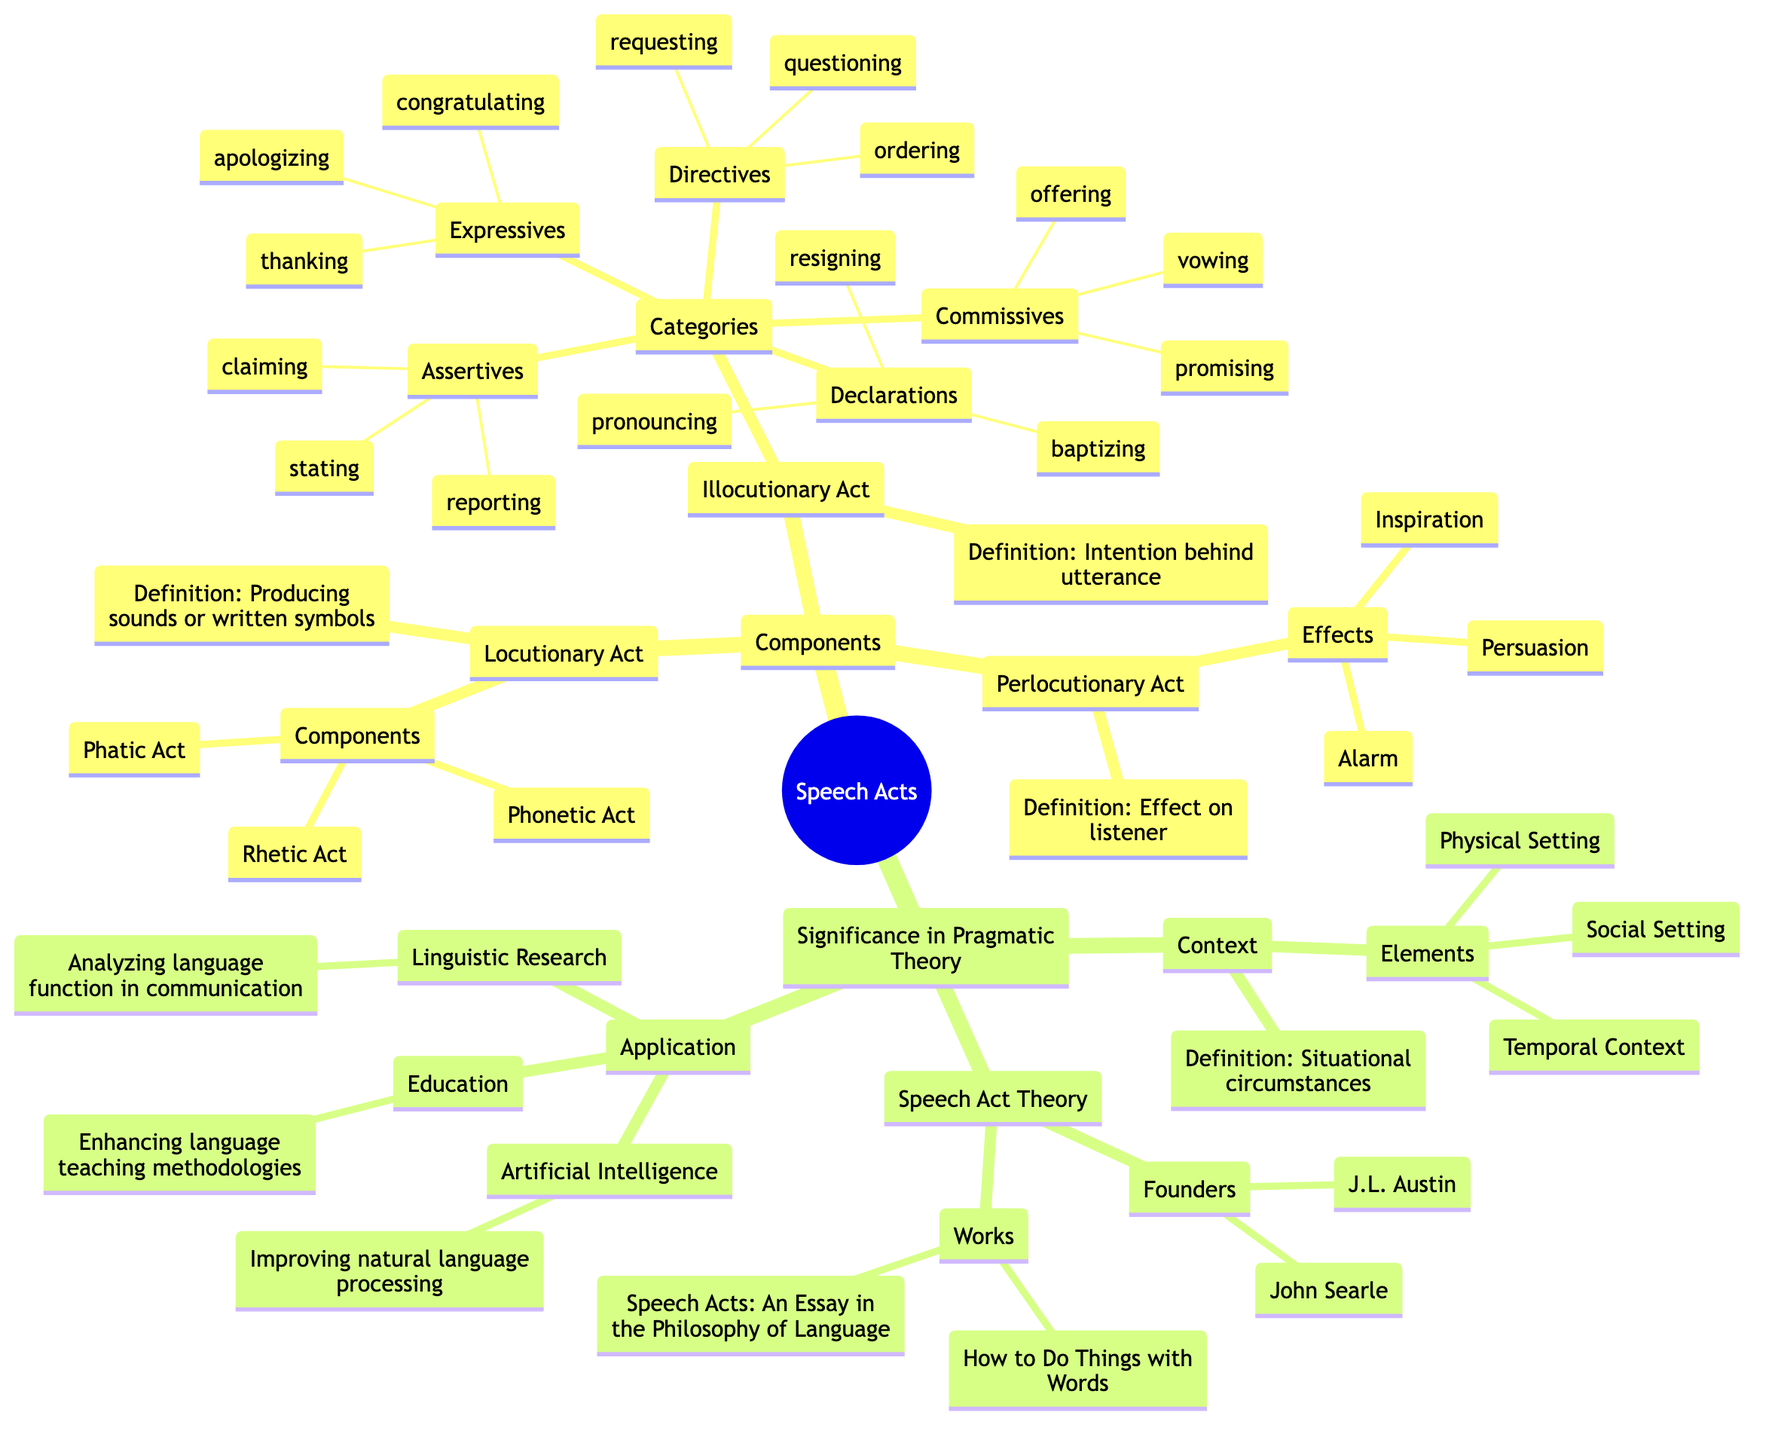What are the components of a Locutionary Act? According to the diagram, a Locutionary Act consists of three components: Phonetic Act, Phatic Act, and Rhetic Act.
Answer: Phonetic Act, Phatic Act, Rhetic Act Who are the founders of Speech Act Theory? The diagram identifies J.L. Austin and John Searle as the founders of Speech Act Theory.
Answer: J.L. Austin, John Searle What is the definition of an Illocutionary Act? The diagram defines an Illocutionary Act as the intention behind the utterance.
Answer: Intention behind utterance How many categories are there in Illocutionary Acts? The diagram lists five categories of Illocutionary Acts: Assertives, Directives, Commissives, Expressives, and Declarations, indicating that there are five categories.
Answer: Five What effect can a Perlocutionary Act have on the listener? The diagram states that the effects of a Perlocutionary Act include Persuasion, Inspiration, and Alarm.
Answer: Persuasion, Inspiration, Alarm What situational elements are considered in the context of speech acts? The Context in the diagram includes three elements: Physical Setting, Social Setting, and Temporal Context.
Answer: Physical Setting, Social Setting, Temporal Context Which work is associated with J.L. Austin in Speech Act Theory? The diagram connects J.L. Austin with the work titled "How to Do Things with Words" in Speech Act Theory.
Answer: How to Do Things with Words What is one application of Speech Act Theory in Artificial Intelligence? The diagram shows that in Artificial Intelligence, Speech Act Theory is applied for improving natural language processing systems.
Answer: Improving natural language processing systems What type of speech act involves promising or vowing? The diagram reveals that Commissives are the type of speech acts that involve actions such as promising or vowing.
Answer: Commissives 